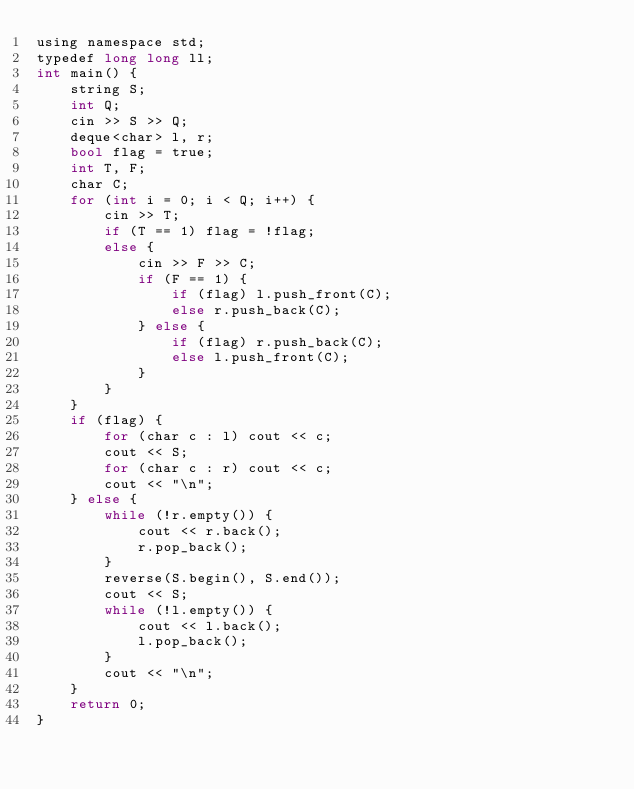Convert code to text. <code><loc_0><loc_0><loc_500><loc_500><_Python_>using namespace std;
typedef long long ll;
int main() {
    string S;
    int Q;
    cin >> S >> Q;
    deque<char> l, r;
    bool flag = true;
    int T, F;
    char C;
    for (int i = 0; i < Q; i++) {
        cin >> T;
        if (T == 1) flag = !flag;
        else {
            cin >> F >> C;
            if (F == 1) {
                if (flag) l.push_front(C);
                else r.push_back(C);
            } else {
                if (flag) r.push_back(C);
                else l.push_front(C);
            }
        }
    }
    if (flag) {
        for (char c : l) cout << c;
        cout << S;
        for (char c : r) cout << c;
        cout << "\n";
    } else {
        while (!r.empty()) {
            cout << r.back();
            r.pop_back();
        }
        reverse(S.begin(), S.end());
        cout << S;
        while (!l.empty()) {
            cout << l.back();
            l.pop_back();
        }
        cout << "\n";
    }
    return 0;
}</code> 